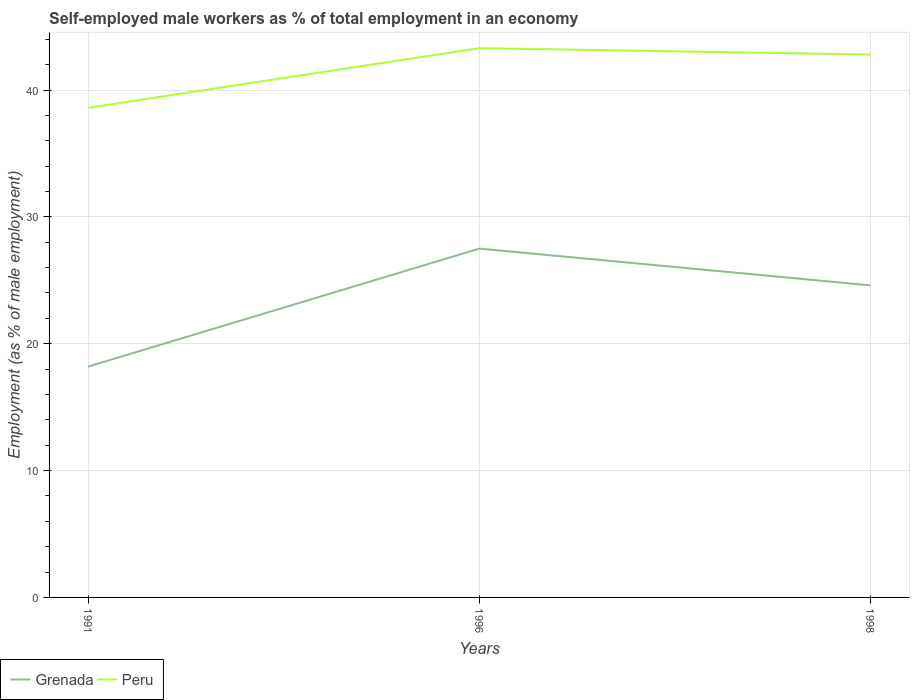Is the number of lines equal to the number of legend labels?
Provide a short and direct response. Yes. Across all years, what is the maximum percentage of self-employed male workers in Grenada?
Give a very brief answer. 18.2. What is the total percentage of self-employed male workers in Grenada in the graph?
Provide a short and direct response. -9.3. What is the difference between the highest and the second highest percentage of self-employed male workers in Grenada?
Offer a very short reply. 9.3. Is the percentage of self-employed male workers in Grenada strictly greater than the percentage of self-employed male workers in Peru over the years?
Your answer should be compact. Yes. How many years are there in the graph?
Give a very brief answer. 3. Does the graph contain any zero values?
Provide a succinct answer. No. How are the legend labels stacked?
Provide a short and direct response. Horizontal. What is the title of the graph?
Your answer should be very brief. Self-employed male workers as % of total employment in an economy. What is the label or title of the X-axis?
Keep it short and to the point. Years. What is the label or title of the Y-axis?
Provide a succinct answer. Employment (as % of male employment). What is the Employment (as % of male employment) in Grenada in 1991?
Give a very brief answer. 18.2. What is the Employment (as % of male employment) in Peru in 1991?
Keep it short and to the point. 38.6. What is the Employment (as % of male employment) of Peru in 1996?
Keep it short and to the point. 43.3. What is the Employment (as % of male employment) of Grenada in 1998?
Keep it short and to the point. 24.6. What is the Employment (as % of male employment) in Peru in 1998?
Provide a short and direct response. 42.8. Across all years, what is the maximum Employment (as % of male employment) of Peru?
Keep it short and to the point. 43.3. Across all years, what is the minimum Employment (as % of male employment) of Grenada?
Offer a terse response. 18.2. Across all years, what is the minimum Employment (as % of male employment) of Peru?
Ensure brevity in your answer.  38.6. What is the total Employment (as % of male employment) of Grenada in the graph?
Provide a succinct answer. 70.3. What is the total Employment (as % of male employment) of Peru in the graph?
Offer a very short reply. 124.7. What is the difference between the Employment (as % of male employment) of Peru in 1991 and that in 1996?
Offer a very short reply. -4.7. What is the difference between the Employment (as % of male employment) in Grenada in 1991 and that in 1998?
Keep it short and to the point. -6.4. What is the difference between the Employment (as % of male employment) in Peru in 1996 and that in 1998?
Provide a short and direct response. 0.5. What is the difference between the Employment (as % of male employment) in Grenada in 1991 and the Employment (as % of male employment) in Peru in 1996?
Offer a very short reply. -25.1. What is the difference between the Employment (as % of male employment) in Grenada in 1991 and the Employment (as % of male employment) in Peru in 1998?
Your answer should be very brief. -24.6. What is the difference between the Employment (as % of male employment) of Grenada in 1996 and the Employment (as % of male employment) of Peru in 1998?
Ensure brevity in your answer.  -15.3. What is the average Employment (as % of male employment) in Grenada per year?
Give a very brief answer. 23.43. What is the average Employment (as % of male employment) of Peru per year?
Ensure brevity in your answer.  41.57. In the year 1991, what is the difference between the Employment (as % of male employment) in Grenada and Employment (as % of male employment) in Peru?
Offer a terse response. -20.4. In the year 1996, what is the difference between the Employment (as % of male employment) of Grenada and Employment (as % of male employment) of Peru?
Offer a very short reply. -15.8. In the year 1998, what is the difference between the Employment (as % of male employment) of Grenada and Employment (as % of male employment) of Peru?
Ensure brevity in your answer.  -18.2. What is the ratio of the Employment (as % of male employment) of Grenada in 1991 to that in 1996?
Ensure brevity in your answer.  0.66. What is the ratio of the Employment (as % of male employment) of Peru in 1991 to that in 1996?
Keep it short and to the point. 0.89. What is the ratio of the Employment (as % of male employment) in Grenada in 1991 to that in 1998?
Your answer should be very brief. 0.74. What is the ratio of the Employment (as % of male employment) in Peru in 1991 to that in 1998?
Your response must be concise. 0.9. What is the ratio of the Employment (as % of male employment) of Grenada in 1996 to that in 1998?
Your answer should be very brief. 1.12. What is the ratio of the Employment (as % of male employment) in Peru in 1996 to that in 1998?
Give a very brief answer. 1.01. What is the difference between the highest and the second highest Employment (as % of male employment) of Peru?
Your answer should be compact. 0.5. What is the difference between the highest and the lowest Employment (as % of male employment) of Peru?
Provide a succinct answer. 4.7. 